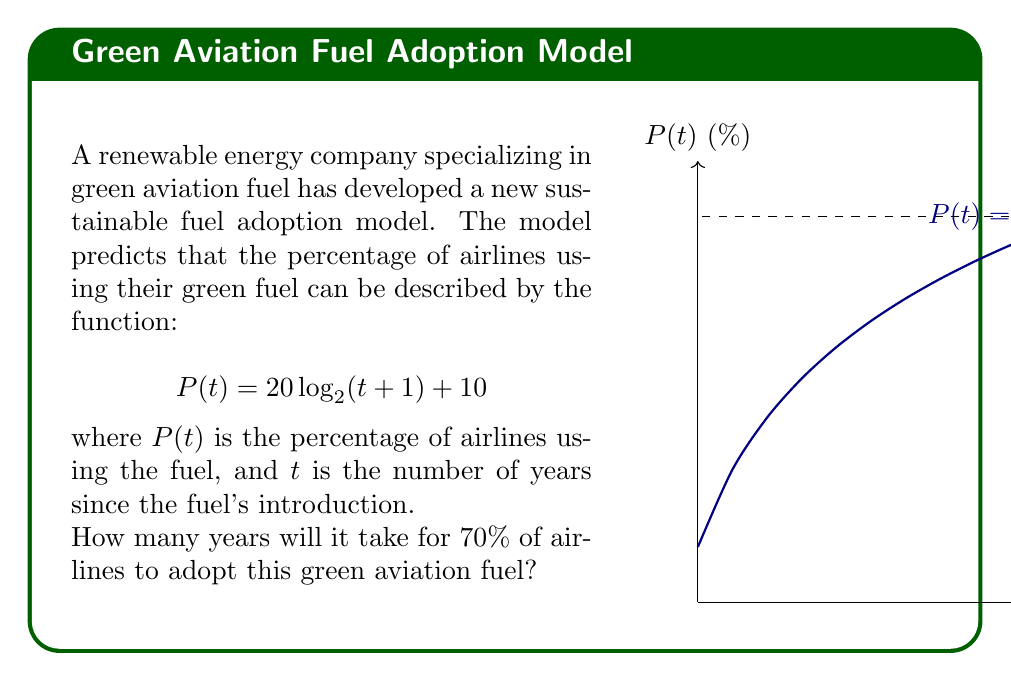Solve this math problem. Let's solve this step-by-step:

1) We need to solve the equation:
   $$70 = 20 \log_2(t+1) + 10$$

2) Subtract 10 from both sides:
   $$60 = 20 \log_2(t+1)$$

3) Divide both sides by 20:
   $$3 = \log_2(t+1)$$

4) To solve for $t$, we need to apply the inverse function of $\log_2$, which is $2^x$:
   $$2^3 = t+1$$

5) Simplify:
   $$8 = t+1$$

6) Subtract 1 from both sides:
   $$7 = t$$

7) However, since we're dealing with years, we need to round up to the nearest whole number:
   $$t = 11$$

Therefore, it will take 11 years for 70% of airlines to adopt this green aviation fuel.
Answer: 11 years 